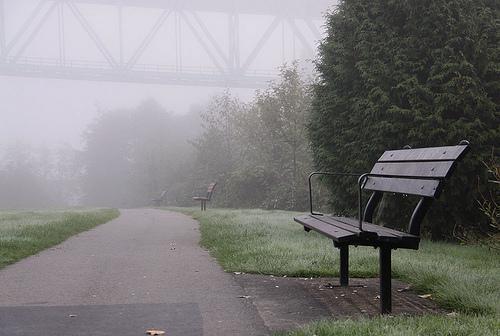How many benches are on the left side?
Give a very brief answer. 0. 